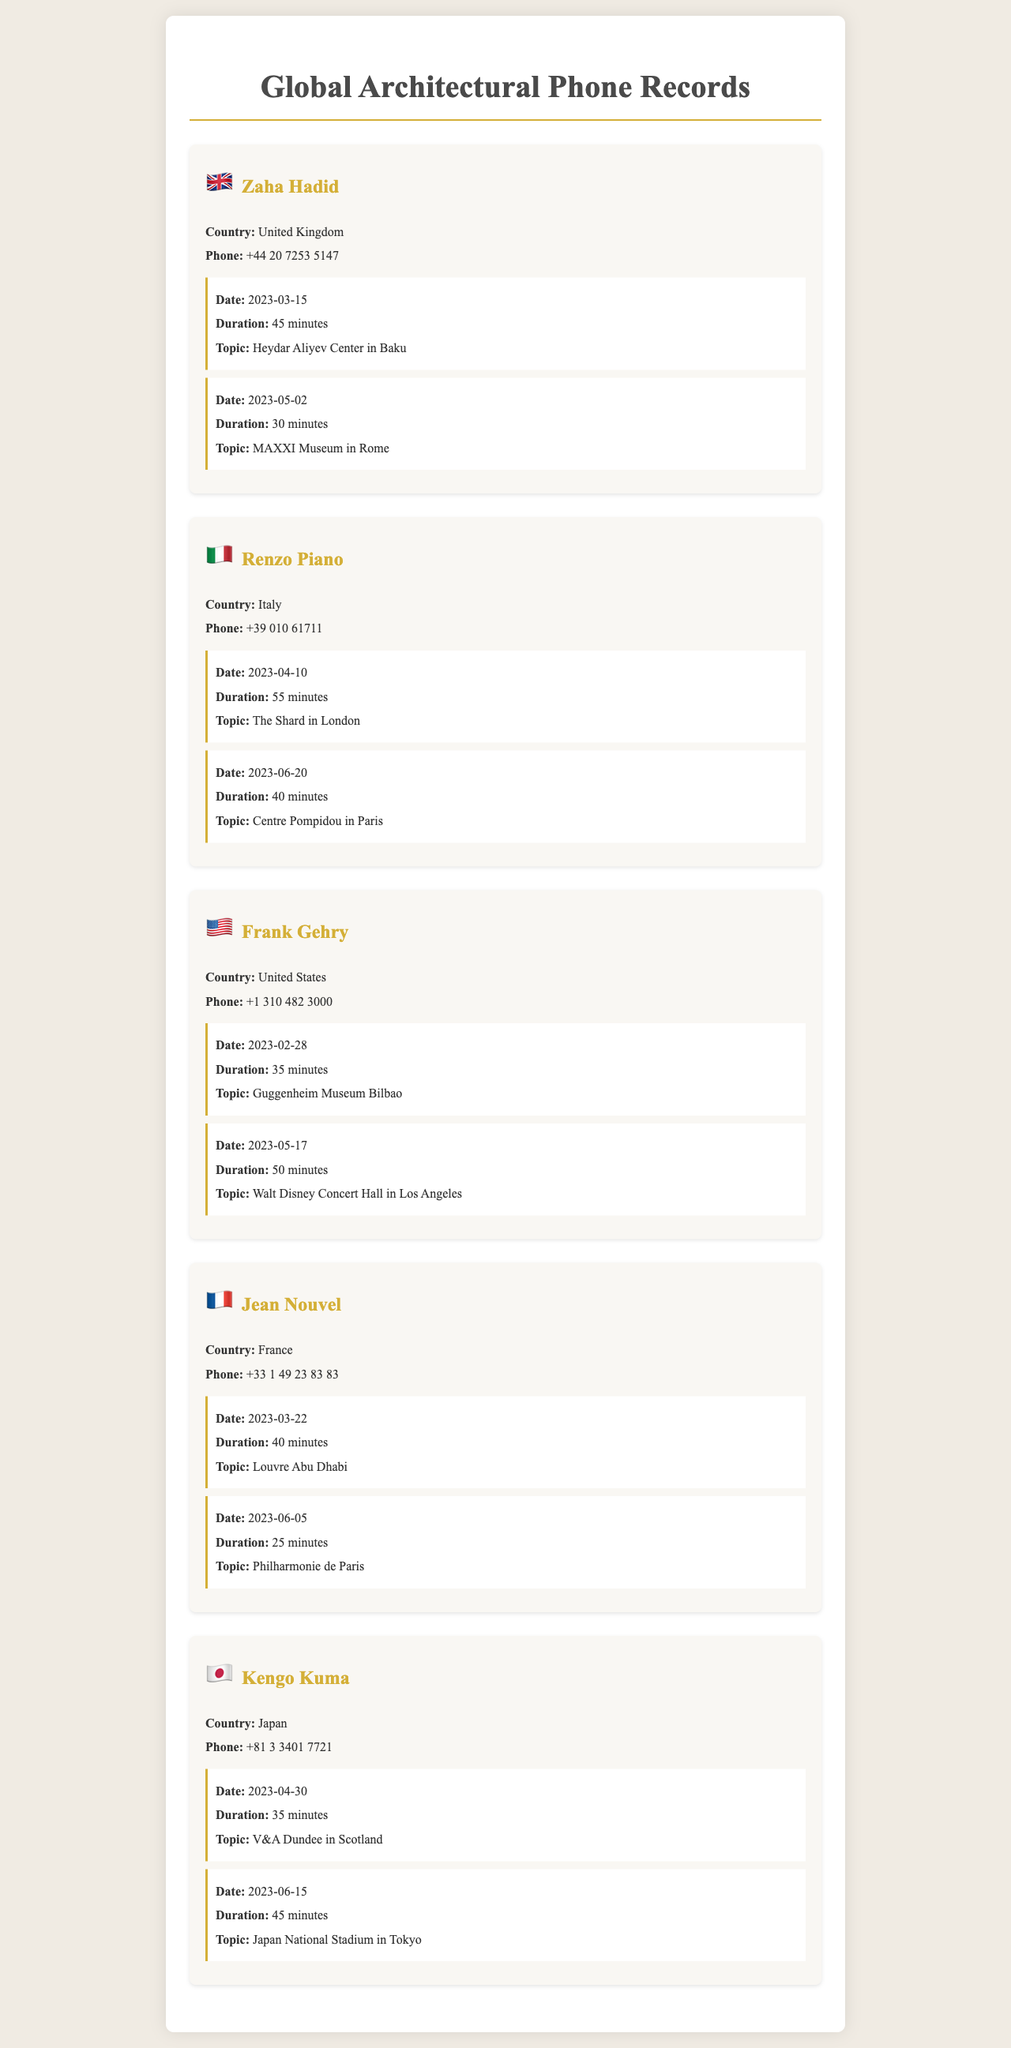what is the name of the architect from the United Kingdom? The document lists Zaha Hadid as the architect from the United Kingdom.
Answer: Zaha Hadid how long was the call with Renzo Piano on April 10, 2023? The call with Renzo Piano on that date lasted for 55 minutes as stated in the document.
Answer: 55 minutes what was the topic of the call with Frank Gehry on February 28, 2023? The document specifies that the topic of the call on that date was the Guggenheim Museum Bilbao.
Answer: Guggenheim Museum Bilbao what is the total call duration for Kengo Kuma? The document lists two call durations: 35 minutes and 45 minutes, totaling 80 minutes.
Answer: 80 minutes how many calls did Jean Nouvel have listed? The document shows that Jean Nouvel had two calls listed.
Answer: 2 calls which architect discussed the Louvre Abu Dhabi? The document indicates that the architect who discussed the Louvre Abu Dhabi is Jean Nouvel.
Answer: Jean Nouvel what is Frank Gehry's phone number? The document provides the phone number for Frank Gehry as +1 310 482 3000.
Answer: +1 310 482 3000 which architect had a call about the MAXXI Museum in Rome? According to the document, Zaha Hadid had a call about the MAXXI Museum in Rome.
Answer: Zaha Hadid when was the call with Kengo Kuma related to Japan National Stadium? The document states that the call regarding Japan National Stadium occurred on June 15, 2023.
Answer: June 15, 2023 